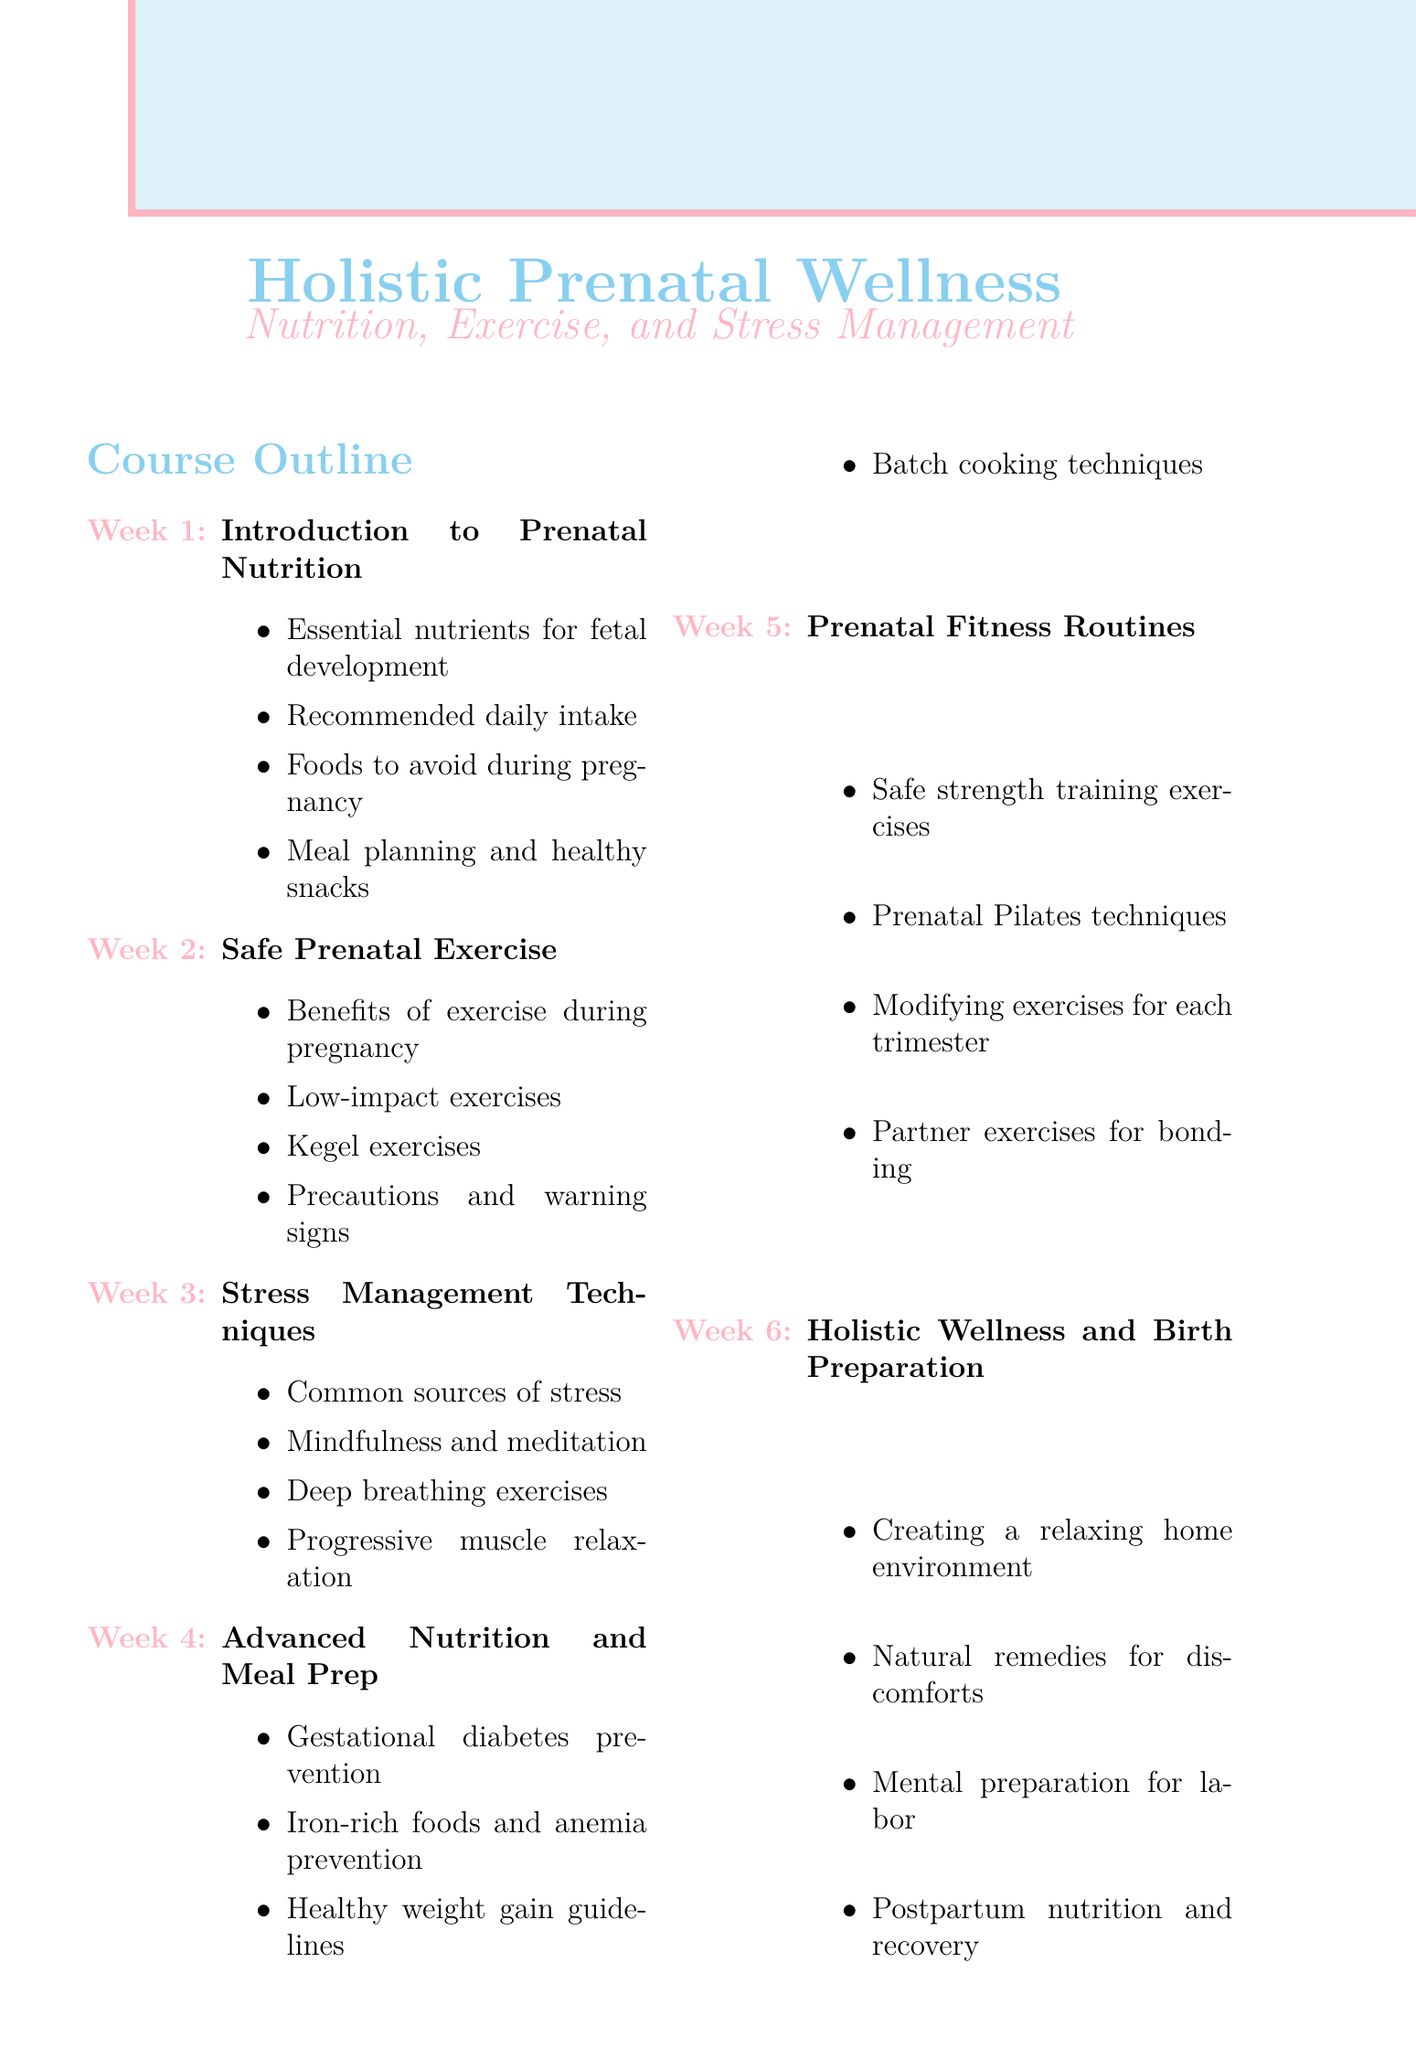What is the title of the class series? The title of the class series is presented at the top of the document, indicating the focus on prenatal wellness.
Answer: Holistic Prenatal Wellness: Nutrition, Exercise, and Stress Management How long is each session in the class series? The document states the duration of each session under course details, specifically mentioning how many hours are allocated.
Answer: 2 hours What week covers 'Safe Prenatal Exercise'? The week number for this topic can be identified in the course outline section.
Answer: Week 2 Which technique is introduced in week 3? The document outlines the key points for each week, allowing for identification of the technique discussed in week 3.
Answer: Stress Management Techniques Who is a guest speaker specialized in prenatal nutrition? The section on guest speakers lists their qualifications, identifying the one focusing on prenatal nutrition.
Answer: Local registered dietitian What is one recommended resource for expectant parents? The document includes a list of recommended resources that can help expectant parents, presenting various titles.
Answer: The Mayo Clinic Guide to a Healthy Pregnancy What key point is discussed in week 4 regarding nutrition? The outline for week 4 includes specific topics related to advanced nutrition that can be directly referred to for the key point.
Answer: Gestational diabetes prevention What is one exercise type mentioned for prenatal fitness? The document provides specific examples of exercises included in the prenatal fitness routines.
Answer: Prenatal Pilates techniques 